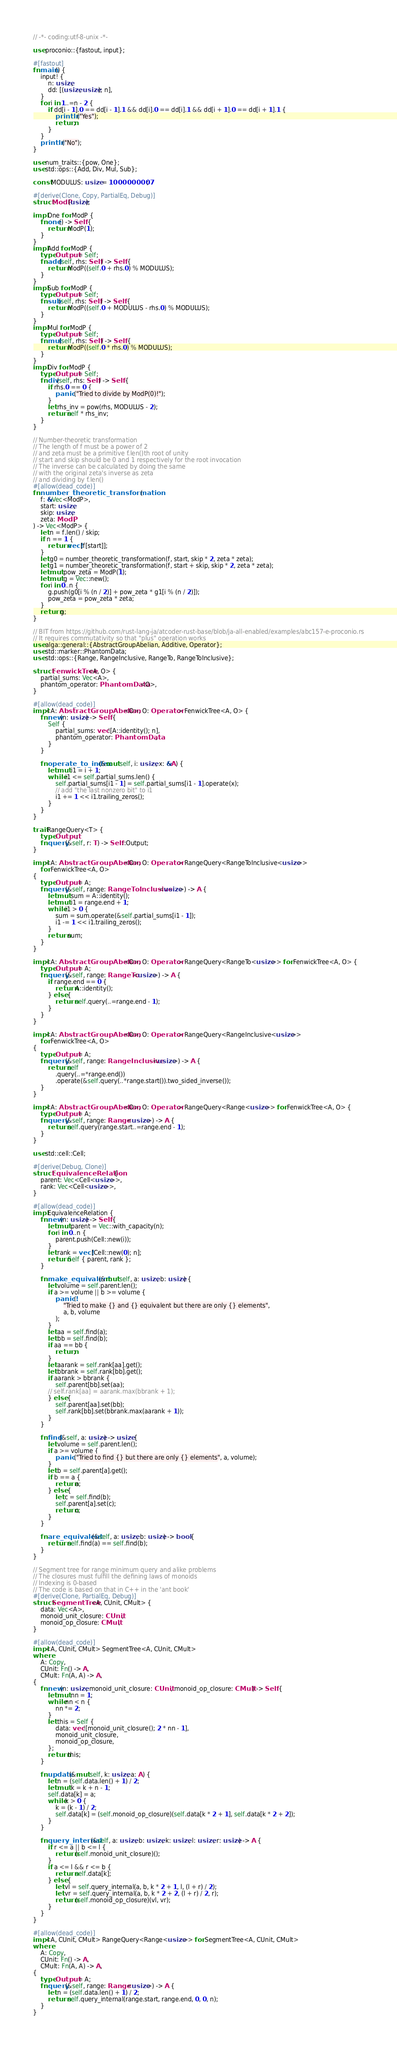Convert code to text. <code><loc_0><loc_0><loc_500><loc_500><_Rust_>// -*- coding:utf-8-unix -*-

use proconio::{fastout, input};

#[fastout]
fn main() {
    input! {
        n: usize,
        dd: [(usize, usize); n],
    }
    for i in 1..=n - 2 {
        if dd[i - 1].0 == dd[i - 1].1 && dd[i].0 == dd[i].1 && dd[i + 1].0 == dd[i + 1].1 {
            println!("Yes");
            return;
        }
    }
    println!("No");
}

use num_traits::{pow, One};
use std::ops::{Add, Div, Mul, Sub};

const MODULUS: usize = 1000000007;

#[derive(Clone, Copy, PartialEq, Debug)]
struct ModP(usize);

impl One for ModP {
    fn one() -> Self {
        return ModP(1);
    }
}
impl Add for ModP {
    type Output = Self;
    fn add(self, rhs: Self) -> Self {
        return ModP((self.0 + rhs.0) % MODULUS);
    }
}
impl Sub for ModP {
    type Output = Self;
    fn sub(self, rhs: Self) -> Self {
        return ModP((self.0 + MODULUS - rhs.0) % MODULUS);
    }
}
impl Mul for ModP {
    type Output = Self;
    fn mul(self, rhs: Self) -> Self {
        return ModP((self.0 * rhs.0) % MODULUS);
    }
}
impl Div for ModP {
    type Output = Self;
    fn div(self, rhs: Self) -> Self {
        if rhs.0 == 0 {
            panic!("Tried to divide by ModP(0)!");
        }
        let rhs_inv = pow(rhs, MODULUS - 2);
        return self * rhs_inv;
    }
}

// Number-theoretic transformation
// The length of f must be a power of 2
// and zeta must be a primitive f.len()th root of unity
// start and skip should be 0 and 1 respectively for the root invocation
// The inverse can be calculated by doing the same
// with the original zeta's inverse as zeta
// and dividing by f.len()
#[allow(dead_code)]
fn number_theoretic_transformation(
    f: &Vec<ModP>,
    start: usize,
    skip: usize,
    zeta: ModP,
) -> Vec<ModP> {
    let n = f.len() / skip;
    if n == 1 {
        return vec![f[start]];
    }
    let g0 = number_theoretic_transformation(f, start, skip * 2, zeta * zeta);
    let g1 = number_theoretic_transformation(f, start + skip, skip * 2, zeta * zeta);
    let mut pow_zeta = ModP(1);
    let mut g = Vec::new();
    for i in 0..n {
        g.push(g0[i % (n / 2)] + pow_zeta * g1[i % (n / 2)]);
        pow_zeta = pow_zeta * zeta;
    }
    return g;
}

// BIT from https://github.com/rust-lang-ja/atcoder-rust-base/blob/ja-all-enabled/examples/abc157-e-proconio.rs
// It requires commutativity so that "plus" operation works
use alga::general::{AbstractGroupAbelian, Additive, Operator};
use std::marker::PhantomData;
use std::ops::{Range, RangeInclusive, RangeTo, RangeToInclusive};

struct FenwickTree<A, O> {
    partial_sums: Vec<A>,
    phantom_operator: PhantomData<O>,
}

#[allow(dead_code)]
impl<A: AbstractGroupAbelian<O>, O: Operator> FenwickTree<A, O> {
    fn new(n: usize) -> Self {
        Self {
            partial_sums: vec![A::identity(); n],
            phantom_operator: PhantomData,
        }
    }

    fn operate_to_index(&mut self, i: usize, x: &A) {
        let mut i1 = i + 1;
        while i1 <= self.partial_sums.len() {
            self.partial_sums[i1 - 1] = self.partial_sums[i1 - 1].operate(x);
            // add "the last nonzero bit" to i1
            i1 += 1 << i1.trailing_zeros();
        }
    }
}

trait RangeQuery<T> {
    type Output;
    fn query(&self, r: T) -> Self::Output;
}

impl<A: AbstractGroupAbelian<O>, O: Operator> RangeQuery<RangeToInclusive<usize>>
    for FenwickTree<A, O>
{
    type Output = A;
    fn query(&self, range: RangeToInclusive<usize>) -> A {
        let mut sum = A::identity();
        let mut i1 = range.end + 1;
        while i1 > 0 {
            sum = sum.operate(&self.partial_sums[i1 - 1]);
            i1 -= 1 << i1.trailing_zeros();
        }
        return sum;
    }
}

impl<A: AbstractGroupAbelian<O>, O: Operator> RangeQuery<RangeTo<usize>> for FenwickTree<A, O> {
    type Output = A;
    fn query(&self, range: RangeTo<usize>) -> A {
        if range.end == 0 {
            return A::identity();
        } else {
            return self.query(..=range.end - 1);
        }
    }
}

impl<A: AbstractGroupAbelian<O>, O: Operator> RangeQuery<RangeInclusive<usize>>
    for FenwickTree<A, O>
{
    type Output = A;
    fn query(&self, range: RangeInclusive<usize>) -> A {
        return self
            .query(..=*range.end())
            .operate(&self.query(..*range.start()).two_sided_inverse());
    }
}

impl<A: AbstractGroupAbelian<O>, O: Operator> RangeQuery<Range<usize>> for FenwickTree<A, O> {
    type Output = A;
    fn query(&self, range: Range<usize>) -> A {
        return self.query(range.start..=range.end - 1);
    }
}

use std::cell::Cell;

#[derive(Debug, Clone)]
struct EquivalenceRelation {
    parent: Vec<Cell<usize>>,
    rank: Vec<Cell<usize>>,
}

#[allow(dead_code)]
impl EquivalenceRelation {
    fn new(n: usize) -> Self {
        let mut parent = Vec::with_capacity(n);
        for i in 0..n {
            parent.push(Cell::new(i));
        }
        let rank = vec![Cell::new(0); n];
        return Self { parent, rank };
    }

    fn make_equivalent(&mut self, a: usize, b: usize) {
        let volume = self.parent.len();
        if a >= volume || b >= volume {
            panic!(
                "Tried to make {} and {} equivalent but there are only {} elements",
                a, b, volume
            );
        }
        let aa = self.find(a);
        let bb = self.find(b);
        if aa == bb {
            return;
        }
        let aarank = self.rank[aa].get();
        let bbrank = self.rank[bb].get();
        if aarank > bbrank {
            self.parent[bb].set(aa);
        // self.rank[aa] = aarank.max(bbrank + 1);
        } else {
            self.parent[aa].set(bb);
            self.rank[bb].set(bbrank.max(aarank + 1));
        }
    }

    fn find(&self, a: usize) -> usize {
        let volume = self.parent.len();
        if a >= volume {
            panic!("Tried to find {} but there are only {} elements", a, volume);
        }
        let b = self.parent[a].get();
        if b == a {
            return a;
        } else {
            let c = self.find(b);
            self.parent[a].set(c);
            return c;
        }
    }

    fn are_equivalent(&self, a: usize, b: usize) -> bool {
        return self.find(a) == self.find(b);
    }
}

// Segment tree for range minimum query and alike problems
// The closures must fulfill the defining laws of monoids
// Indexing is 0-based
// The code is based on that in C++ in the 'ant book'
#[derive(Clone, PartialEq, Debug)]
struct SegmentTree<A, CUnit, CMult> {
    data: Vec<A>,
    monoid_unit_closure: CUnit,
    monoid_op_closure: CMult,
}

#[allow(dead_code)]
impl<A, CUnit, CMult> SegmentTree<A, CUnit, CMult>
where
    A: Copy,
    CUnit: Fn() -> A,
    CMult: Fn(A, A) -> A,
{
    fn new(n: usize, monoid_unit_closure: CUnit, monoid_op_closure: CMult) -> Self {
        let mut nn = 1;
        while nn < n {
            nn *= 2;
        }
        let this = Self {
            data: vec![monoid_unit_closure(); 2 * nn - 1],
            monoid_unit_closure,
            monoid_op_closure,
        };
        return this;
    }

    fn update(&mut self, k: usize, a: A) {
        let n = (self.data.len() + 1) / 2;
        let mut k = k + n - 1;
        self.data[k] = a;
        while k > 0 {
            k = (k - 1) / 2;
            self.data[k] = (self.monoid_op_closure)(self.data[k * 2 + 1], self.data[k * 2 + 2]);
        }
    }

    fn query_internal(&self, a: usize, b: usize, k: usize, l: usize, r: usize) -> A {
        if r <= a || b <= l {
            return (self.monoid_unit_closure)();
        }
        if a <= l && r <= b {
            return self.data[k];
        } else {
            let vl = self.query_internal(a, b, k * 2 + 1, l, (l + r) / 2);
            let vr = self.query_internal(a, b, k * 2 + 2, (l + r) / 2, r);
            return (self.monoid_op_closure)(vl, vr);
        }
    }
}

#[allow(dead_code)]
impl<A, CUnit, CMult> RangeQuery<Range<usize>> for SegmentTree<A, CUnit, CMult>
where
    A: Copy,
    CUnit: Fn() -> A,
    CMult: Fn(A, A) -> A,
{
    type Output = A;
    fn query(&self, range: Range<usize>) -> A {
        let n = (self.data.len() + 1) / 2;
        return self.query_internal(range.start, range.end, 0, 0, n);
    }
}
</code> 